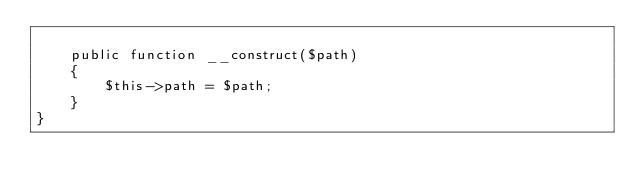Convert code to text. <code><loc_0><loc_0><loc_500><loc_500><_PHP_>
    public function __construct($path)
    {
        $this->path = $path;
    }
}
</code> 